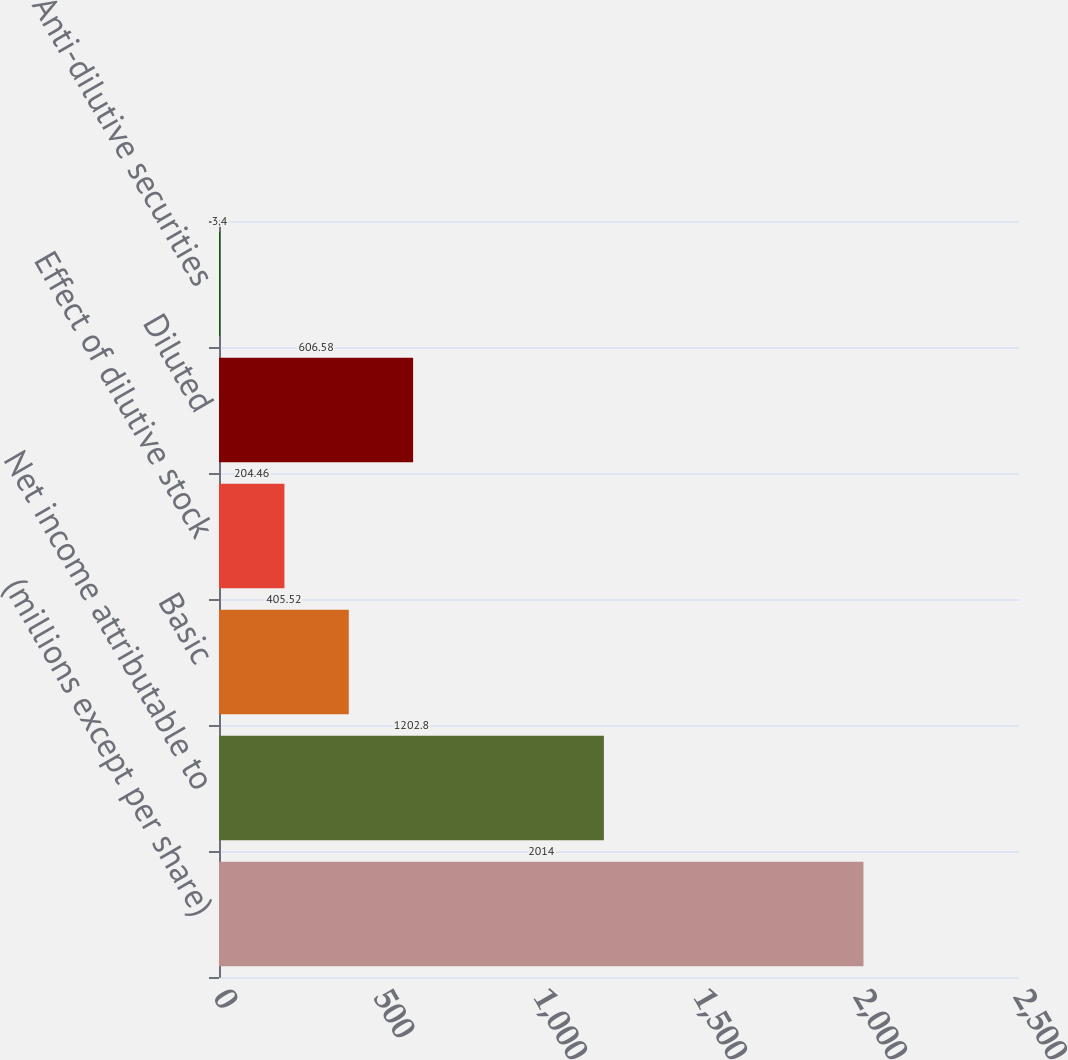Convert chart. <chart><loc_0><loc_0><loc_500><loc_500><bar_chart><fcel>(millions except per share)<fcel>Net income attributable to<fcel>Basic<fcel>Effect of dilutive stock<fcel>Diluted<fcel>Anti-dilutive securities<nl><fcel>2014<fcel>1202.8<fcel>405.52<fcel>204.46<fcel>606.58<fcel>3.4<nl></chart> 